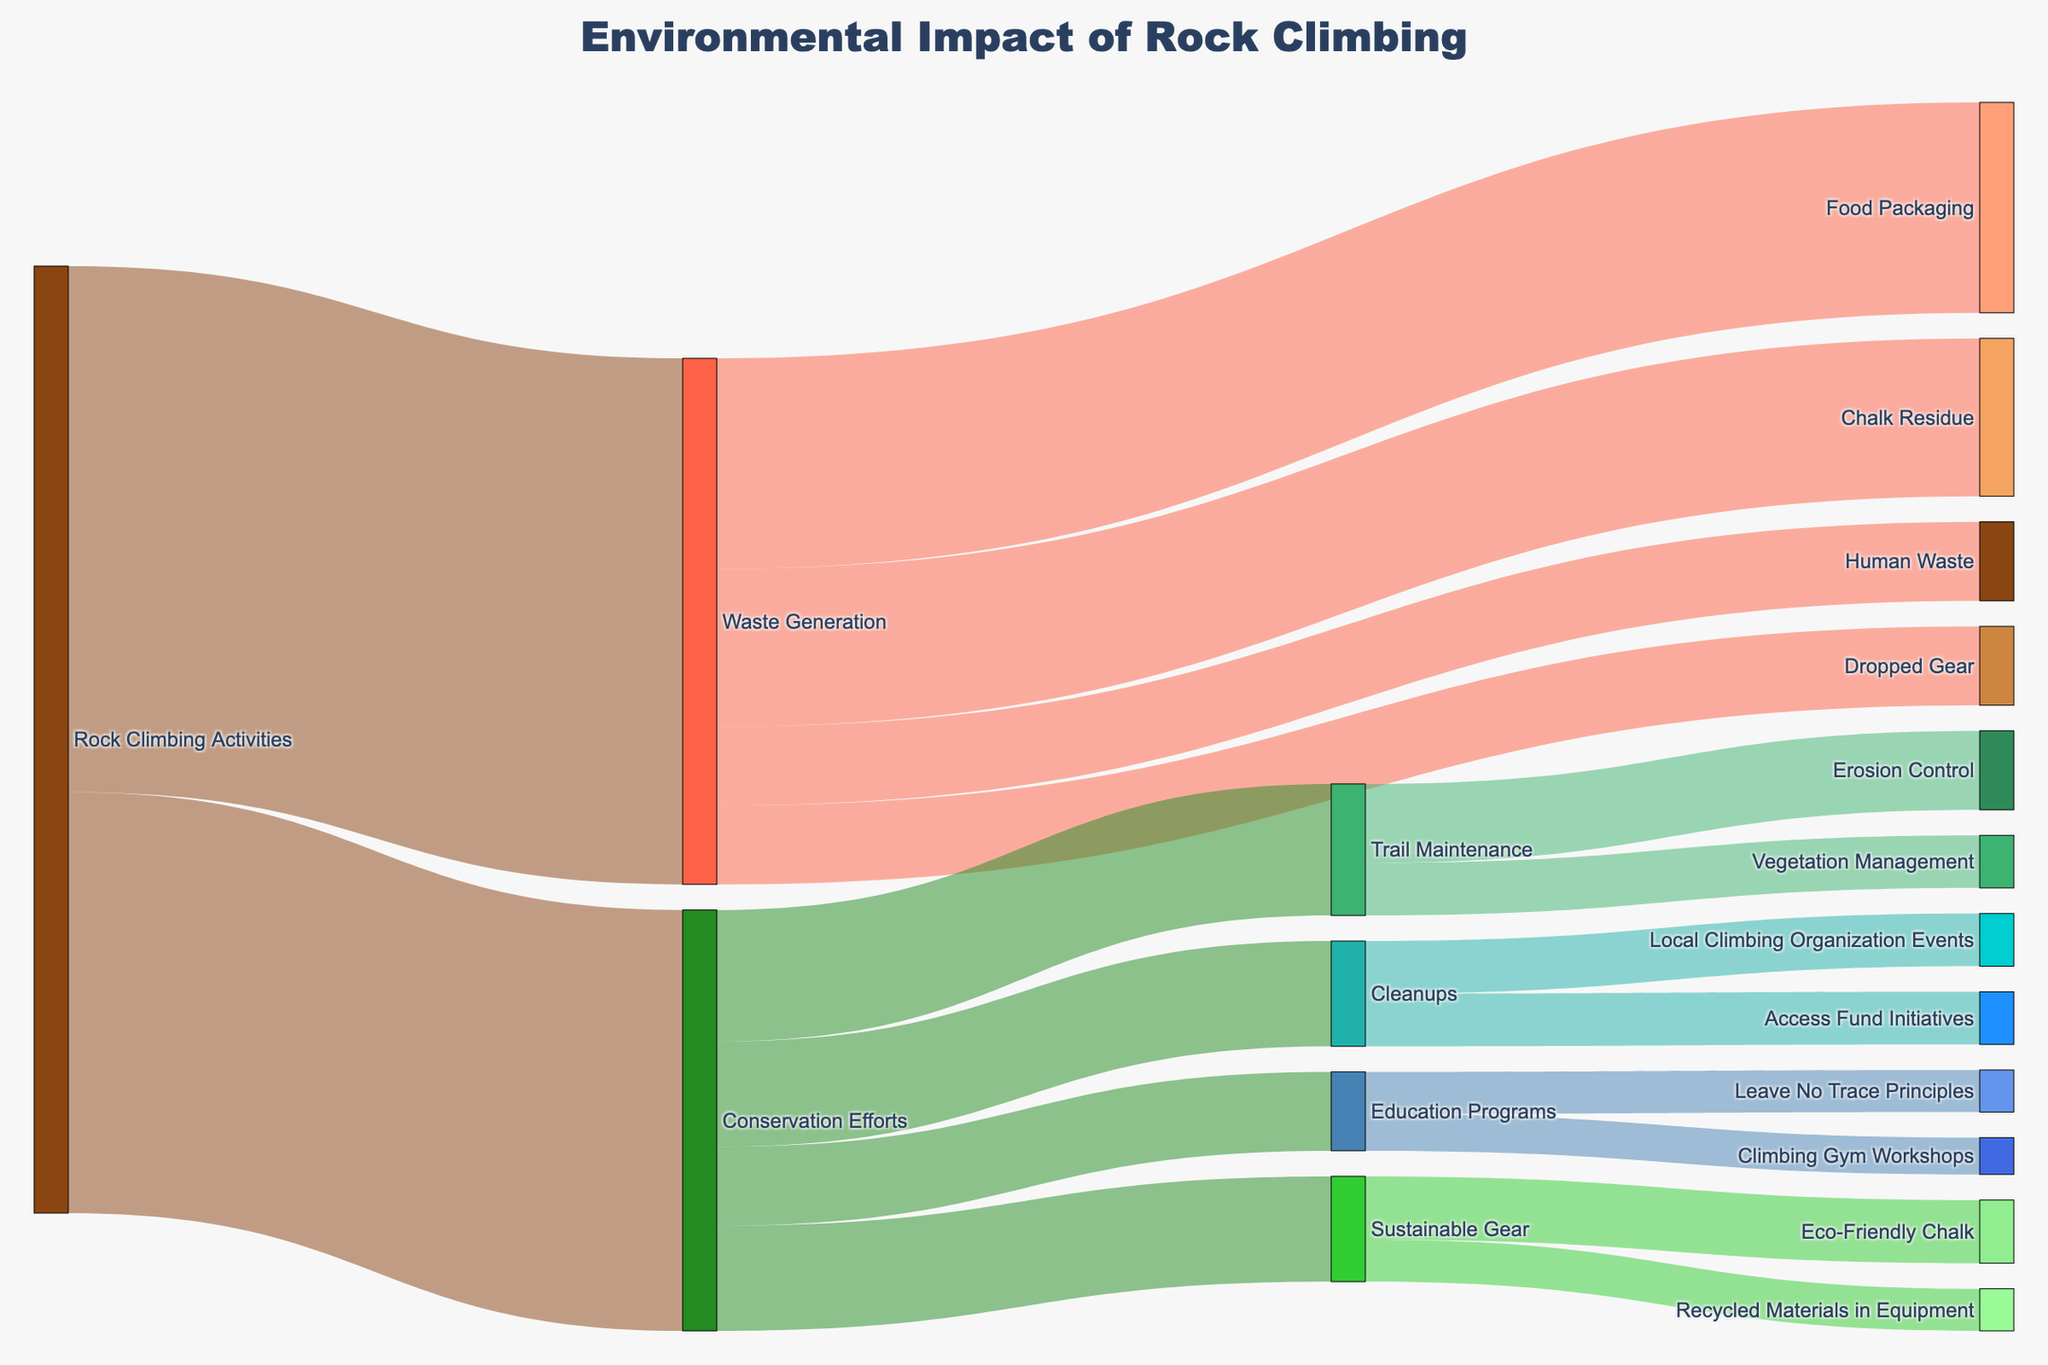What is the title of the figure? The title is prominently displayed at the top of the figure, which summarizes the visual representation.
Answer: Environmental Impact of Rock Climbing How much waste is related to food packaging? By looking at the path connecting Waste Generation to Food Packaging, you can see the magnitude.
Answer: 40 Which conservation effort receives the most significant value allocation from rock climbing activities? Compare the values allocated to Trail Maintenance, Cleanups, Education Programs, and Sustainable Gear stemming from Conservation Efforts.
Answer: Trail Maintenance What is the combined total value for Chalk Residue and Dropped Gear? Sum the values from the paths that link Waste Generation to Chalk Residue and Dropped Gear. 30 + 15 = 45
Answer: 45 Which effort is more involved in cleanups, Access Fund Initiatives or Local Climbing Organization Events? Compare the values connected directly from Cleanups to both Access Fund Initiatives and Local Climbing Organization Events.
Answer: Access Fund Initiatives and Local Climbing Organization Events are equal Between Education Programs and Sustainable Gear, which received more value from Conservation Efforts? Compare the magnitudes allocated from Conservation Efforts to both Education Programs and Sustainable Gear.
Answer: Sustainable Gear Sum the values related to Erosion Control and Vegetation Management. Sum the values of the paths Trail Maintenance to Erosion Control and Trail Maintenance to Vegetation Management, 15 + 10 = 25
Answer: 25 How much value is allocated to Leave No Trace Principles under Education Programs? Follow the path that connects Education Programs to Leave No Trace Principles and observe the value.
Answer: 8 Which source category takes up a larger share from Rock Climbing Activities, Waste Generation or Conservation Efforts? Compare the overall values stemming directly from Rock Climbing Activities to Waste Generation and Conservation Efforts.
Answer: Waste Generation What is the value allocated to Recycled Materials in Equipment? Observe the path connection from Sustainable Gear to Recycled Materials in Equipment and note the value.
Answer: 8 